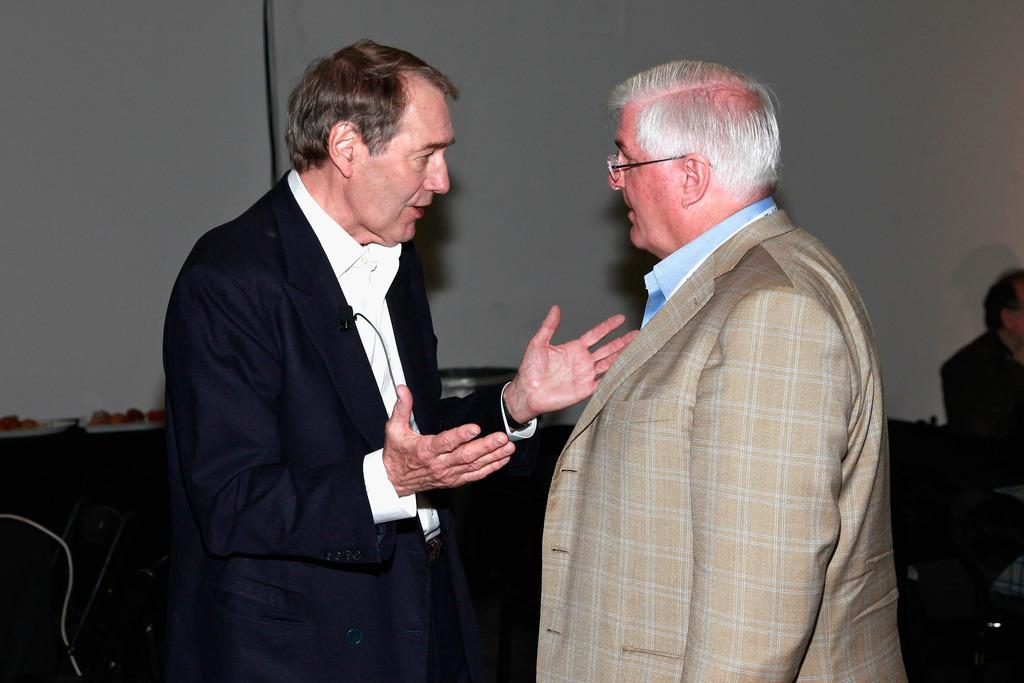How many people are in the center of the image? There are two persons in the center of the image. What are the two persons in the center doing? The two persons in the center are talking with each other. Can you describe the setting in the image? There are tables and chairs in the image, and there is a wall in the background. Are there any other people visible in the image? Yes, there is another person in the background of the image. What type of rings can be seen on the person's fingers in the image? There are no rings visible on any person's fingers in the image. How many planes are flying in the background of the image? There are no planes visible in the image; it only shows people talking in a setting with tables, chairs, and a wall. 